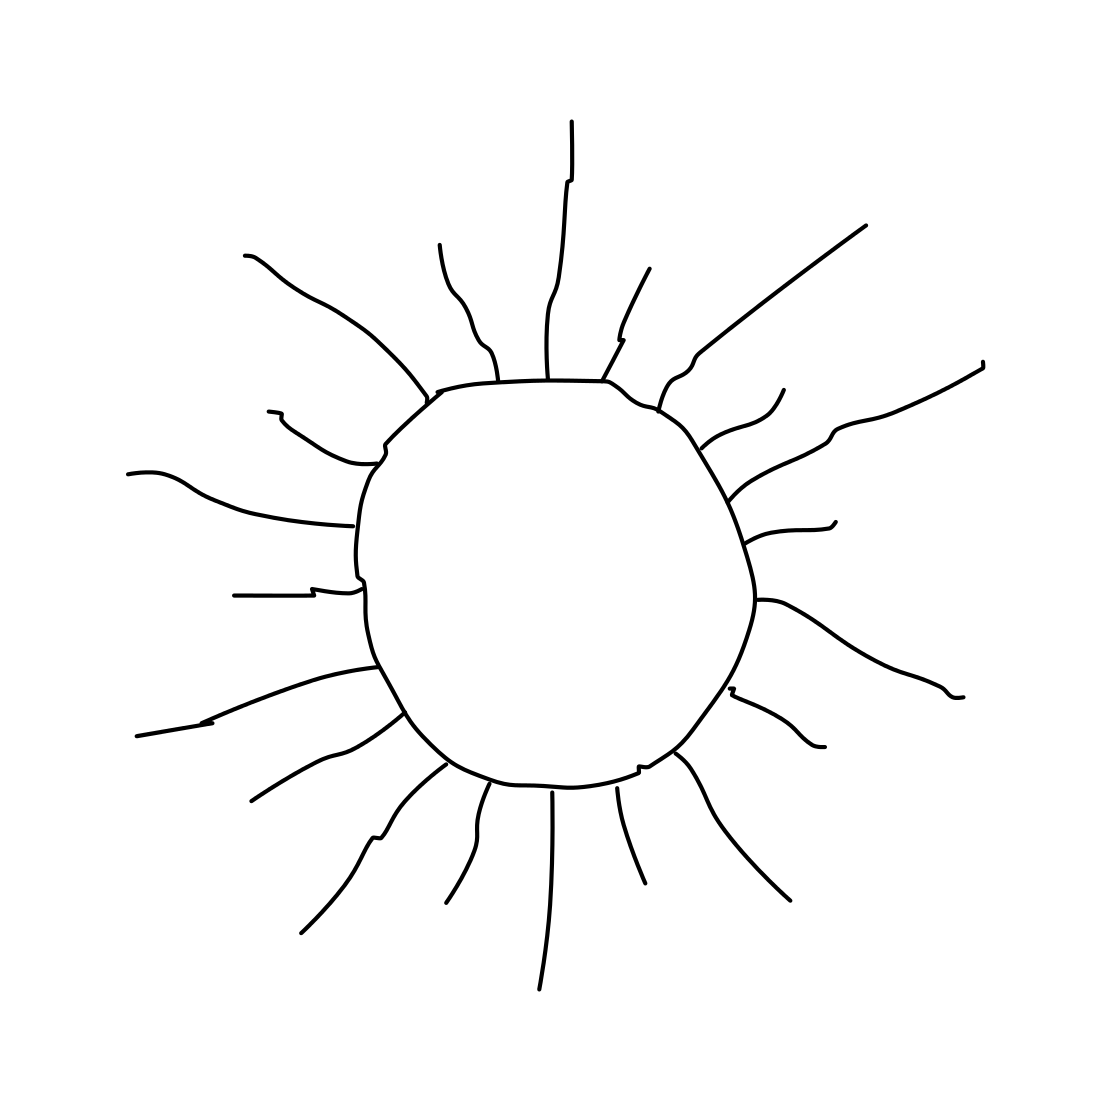In the scene, is a sun in it? Absolutely, the image vividly depicts a sun with radiating beams creating a vibrant, sunny atmosphere. 